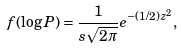<formula> <loc_0><loc_0><loc_500><loc_500>f ( \log P ) = \frac { 1 } { s \sqrt { 2 \pi } } e ^ { - ( 1 / 2 ) z ^ { 2 } } ,</formula> 